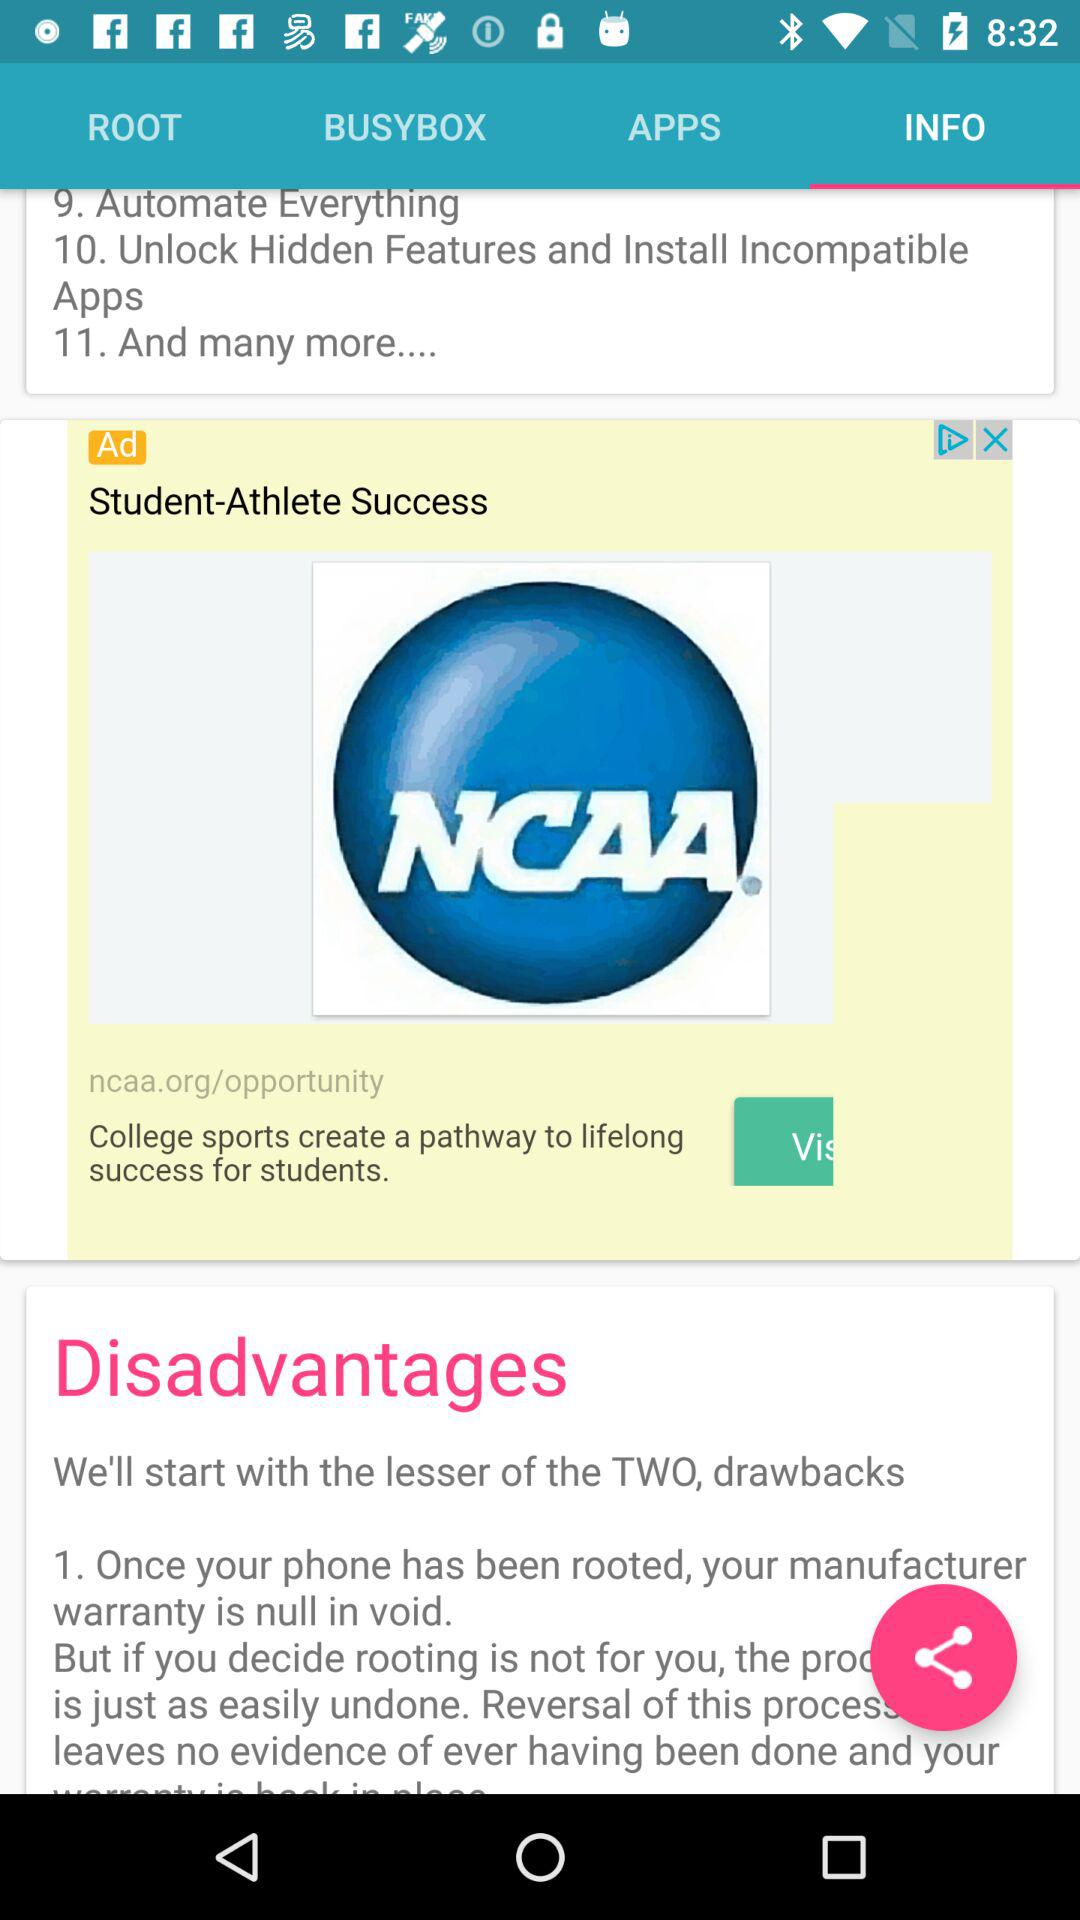How many of the disadvantages are about warranty?
Answer the question using a single word or phrase. 1 